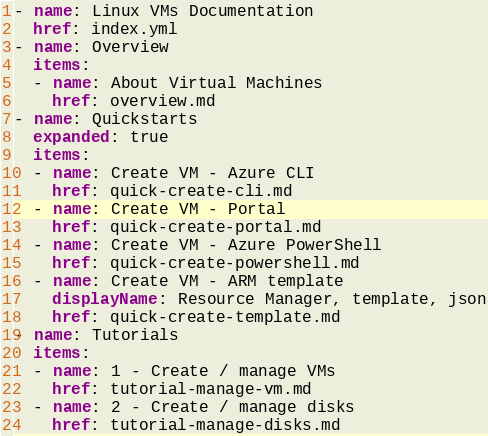Convert code to text. <code><loc_0><loc_0><loc_500><loc_500><_YAML_>- name: Linux VMs Documentation
  href: index.yml
- name: Overview
  items:
  - name: About Virtual Machines
    href: overview.md
- name: Quickstarts
  expanded: true
  items:
  - name: Create VM - Azure CLI
    href: quick-create-cli.md
  - name: Create VM - Portal
    href: quick-create-portal.md
  - name: Create VM - Azure PowerShell
    href: quick-create-powershell.md
  - name: Create VM - ARM template
    displayName: Resource Manager, template, json
    href: quick-create-template.md
- name: Tutorials
  items:
  - name: 1 - Create / manage VMs
    href: tutorial-manage-vm.md
  - name: 2 - Create / manage disks
    href: tutorial-manage-disks.md</code> 